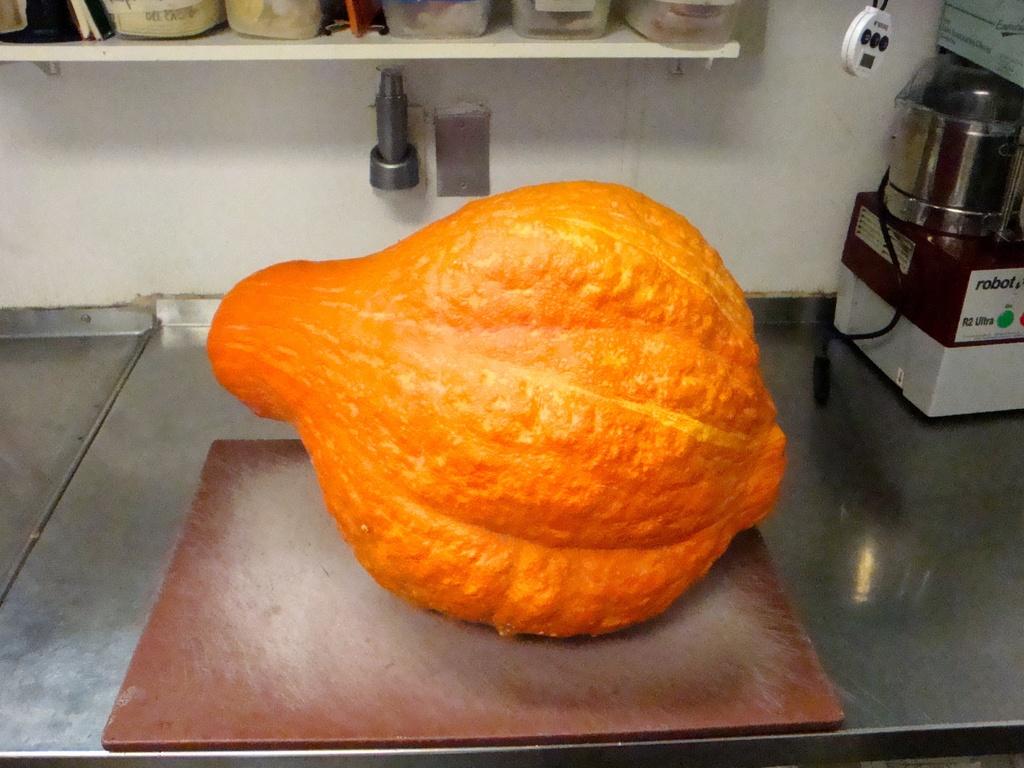What word is on the machine on the right?
Ensure brevity in your answer.  Robot. 